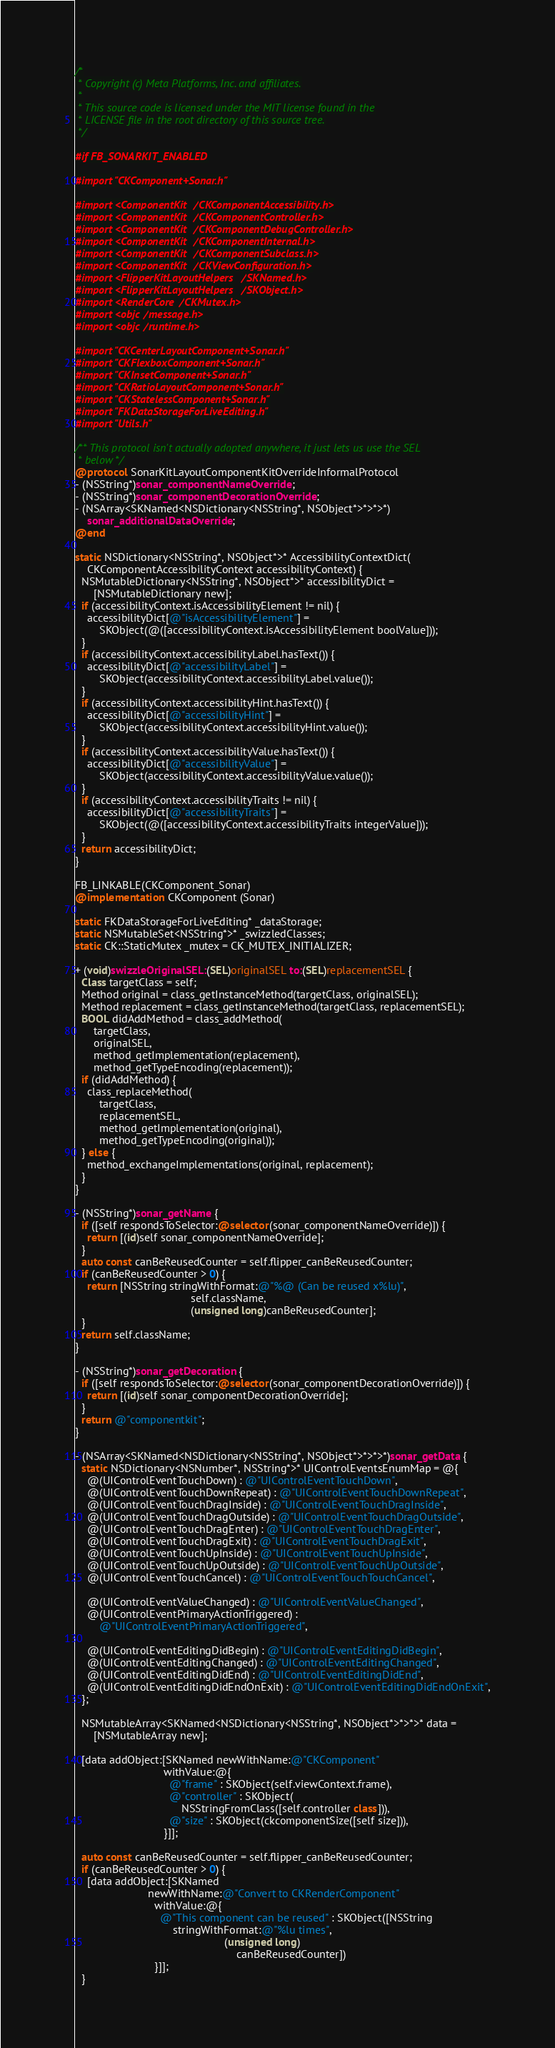Convert code to text. <code><loc_0><loc_0><loc_500><loc_500><_ObjectiveC_>/*
 * Copyright (c) Meta Platforms, Inc. and affiliates.
 *
 * This source code is licensed under the MIT license found in the
 * LICENSE file in the root directory of this source tree.
 */

#if FB_SONARKIT_ENABLED

#import "CKComponent+Sonar.h"

#import <ComponentKit/CKComponentAccessibility.h>
#import <ComponentKit/CKComponentController.h>
#import <ComponentKit/CKComponentDebugController.h>
#import <ComponentKit/CKComponentInternal.h>
#import <ComponentKit/CKComponentSubclass.h>
#import <ComponentKit/CKViewConfiguration.h>
#import <FlipperKitLayoutHelpers/SKNamed.h>
#import <FlipperKitLayoutHelpers/SKObject.h>
#import <RenderCore/CKMutex.h>
#import <objc/message.h>
#import <objc/runtime.h>

#import "CKCenterLayoutComponent+Sonar.h"
#import "CKFlexboxComponent+Sonar.h"
#import "CKInsetComponent+Sonar.h"
#import "CKRatioLayoutComponent+Sonar.h"
#import "CKStatelessComponent+Sonar.h"
#import "FKDataStorageForLiveEditing.h"
#import "Utils.h"

/** This protocol isn't actually adopted anywhere, it just lets us use the SEL
 * below */
@protocol SonarKitLayoutComponentKitOverrideInformalProtocol
- (NSString*)sonar_componentNameOverride;
- (NSString*)sonar_componentDecorationOverride;
- (NSArray<SKNamed<NSDictionary<NSString*, NSObject*>*>*>*)
    sonar_additionalDataOverride;
@end

static NSDictionary<NSString*, NSObject*>* AccessibilityContextDict(
    CKComponentAccessibilityContext accessibilityContext) {
  NSMutableDictionary<NSString*, NSObject*>* accessibilityDict =
      [NSMutableDictionary new];
  if (accessibilityContext.isAccessibilityElement != nil) {
    accessibilityDict[@"isAccessibilityElement"] =
        SKObject(@([accessibilityContext.isAccessibilityElement boolValue]));
  }
  if (accessibilityContext.accessibilityLabel.hasText()) {
    accessibilityDict[@"accessibilityLabel"] =
        SKObject(accessibilityContext.accessibilityLabel.value());
  }
  if (accessibilityContext.accessibilityHint.hasText()) {
    accessibilityDict[@"accessibilityHint"] =
        SKObject(accessibilityContext.accessibilityHint.value());
  }
  if (accessibilityContext.accessibilityValue.hasText()) {
    accessibilityDict[@"accessibilityValue"] =
        SKObject(accessibilityContext.accessibilityValue.value());
  }
  if (accessibilityContext.accessibilityTraits != nil) {
    accessibilityDict[@"accessibilityTraits"] =
        SKObject(@([accessibilityContext.accessibilityTraits integerValue]));
  }
  return accessibilityDict;
}

FB_LINKABLE(CKComponent_Sonar)
@implementation CKComponent (Sonar)

static FKDataStorageForLiveEditing* _dataStorage;
static NSMutableSet<NSString*>* _swizzledClasses;
static CK::StaticMutex _mutex = CK_MUTEX_INITIALIZER;

+ (void)swizzleOriginalSEL:(SEL)originalSEL to:(SEL)replacementSEL {
  Class targetClass = self;
  Method original = class_getInstanceMethod(targetClass, originalSEL);
  Method replacement = class_getInstanceMethod(targetClass, replacementSEL);
  BOOL didAddMethod = class_addMethod(
      targetClass,
      originalSEL,
      method_getImplementation(replacement),
      method_getTypeEncoding(replacement));
  if (didAddMethod) {
    class_replaceMethod(
        targetClass,
        replacementSEL,
        method_getImplementation(original),
        method_getTypeEncoding(original));
  } else {
    method_exchangeImplementations(original, replacement);
  }
}

- (NSString*)sonar_getName {
  if ([self respondsToSelector:@selector(sonar_componentNameOverride)]) {
    return [(id)self sonar_componentNameOverride];
  }
  auto const canBeReusedCounter = self.flipper_canBeReusedCounter;
  if (canBeReusedCounter > 0) {
    return [NSString stringWithFormat:@"%@ (Can be reused x%lu)",
                                      self.className,
                                      (unsigned long)canBeReusedCounter];
  }
  return self.className;
}

- (NSString*)sonar_getDecoration {
  if ([self respondsToSelector:@selector(sonar_componentDecorationOverride)]) {
    return [(id)self sonar_componentDecorationOverride];
  }
  return @"componentkit";
}

- (NSArray<SKNamed<NSDictionary<NSString*, NSObject*>*>*>*)sonar_getData {
  static NSDictionary<NSNumber*, NSString*>* UIControlEventsEnumMap = @{
    @(UIControlEventTouchDown) : @"UIControlEventTouchDown",
    @(UIControlEventTouchDownRepeat) : @"UIControlEventTouchDownRepeat",
    @(UIControlEventTouchDragInside) : @"UIControlEventTouchDragInside",
    @(UIControlEventTouchDragOutside) : @"UIControlEventTouchDragOutside",
    @(UIControlEventTouchDragEnter) : @"UIControlEventTouchDragEnter",
    @(UIControlEventTouchDragExit) : @"UIControlEventTouchDragExit",
    @(UIControlEventTouchUpInside) : @"UIControlEventTouchUpInside",
    @(UIControlEventTouchUpOutside) : @"UIControlEventTouchUpOutside",
    @(UIControlEventTouchCancel) : @"UIControlEventTouchTouchCancel",

    @(UIControlEventValueChanged) : @"UIControlEventValueChanged",
    @(UIControlEventPrimaryActionTriggered) :
        @"UIControlEventPrimaryActionTriggered",

    @(UIControlEventEditingDidBegin) : @"UIControlEventEditingDidBegin",
    @(UIControlEventEditingChanged) : @"UIControlEventEditingChanged",
    @(UIControlEventEditingDidEnd) : @"UIControlEventEditingDidEnd",
    @(UIControlEventEditingDidEndOnExit) : @"UIControlEventEditingDidEndOnExit",
  };

  NSMutableArray<SKNamed<NSDictionary<NSString*, NSObject*>*>*>* data =
      [NSMutableArray new];

  [data addObject:[SKNamed newWithName:@"CKComponent"
                             withValue:@{
                               @"frame" : SKObject(self.viewContext.frame),
                               @"controller" : SKObject(
                                   NSStringFromClass([self.controller class])),
                               @"size" : SKObject(ckcomponentSize([self size])),
                             }]];

  auto const canBeReusedCounter = self.flipper_canBeReusedCounter;
  if (canBeReusedCounter > 0) {
    [data addObject:[SKNamed
                        newWithName:@"Convert to CKRenderComponent"
                          withValue:@{
                            @"This component can be reused" : SKObject([NSString
                                stringWithFormat:@"%lu times",
                                                 (unsigned long)
                                                     canBeReusedCounter])
                          }]];
  }
</code> 